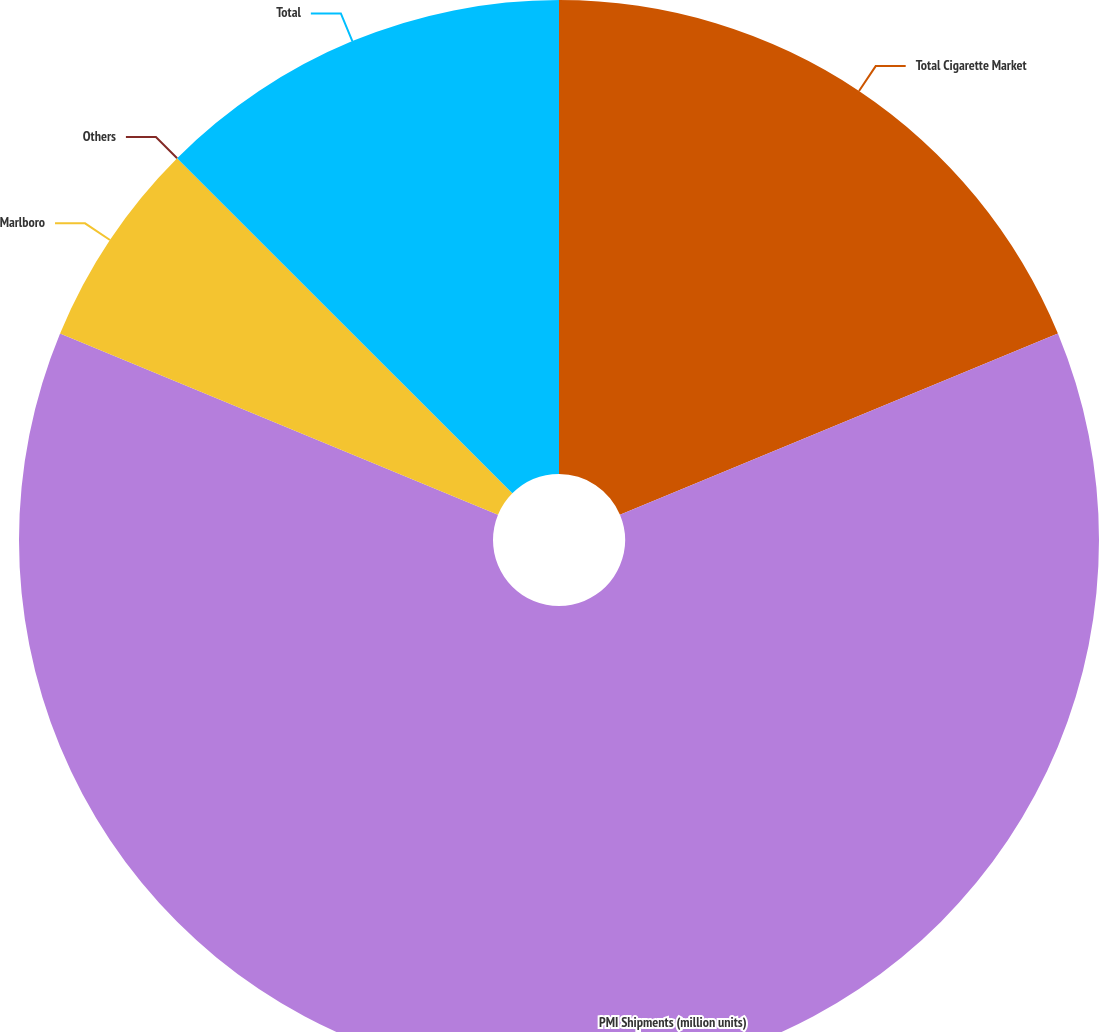Convert chart. <chart><loc_0><loc_0><loc_500><loc_500><pie_chart><fcel>Total Cigarette Market<fcel>PMI Shipments (million units)<fcel>Marlboro<fcel>Others<fcel>Total<nl><fcel>18.75%<fcel>62.49%<fcel>6.25%<fcel>0.0%<fcel>12.5%<nl></chart> 